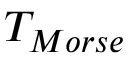<formula> <loc_0><loc_0><loc_500><loc_500>T _ { M o r s e }</formula> 